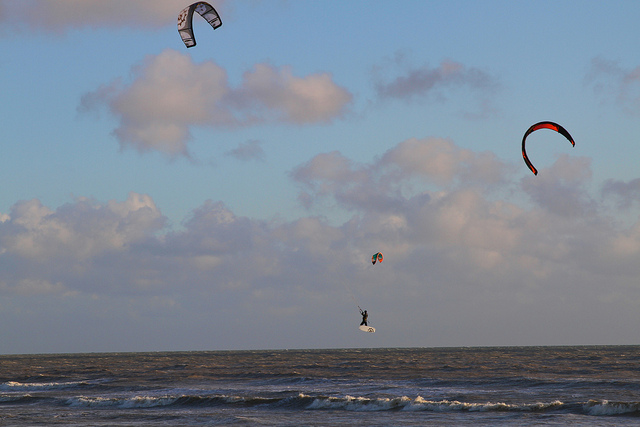Can you describe the main objects you see in the image? The image captures the essence of the sea with its rolling waves near the shore. Dotting the sky are three intricate kites dancing in the breeze, with a kite surfer elegantly maneuvering on a board below, appearing almost as an integral part of this dynamic aquatic ballet. 